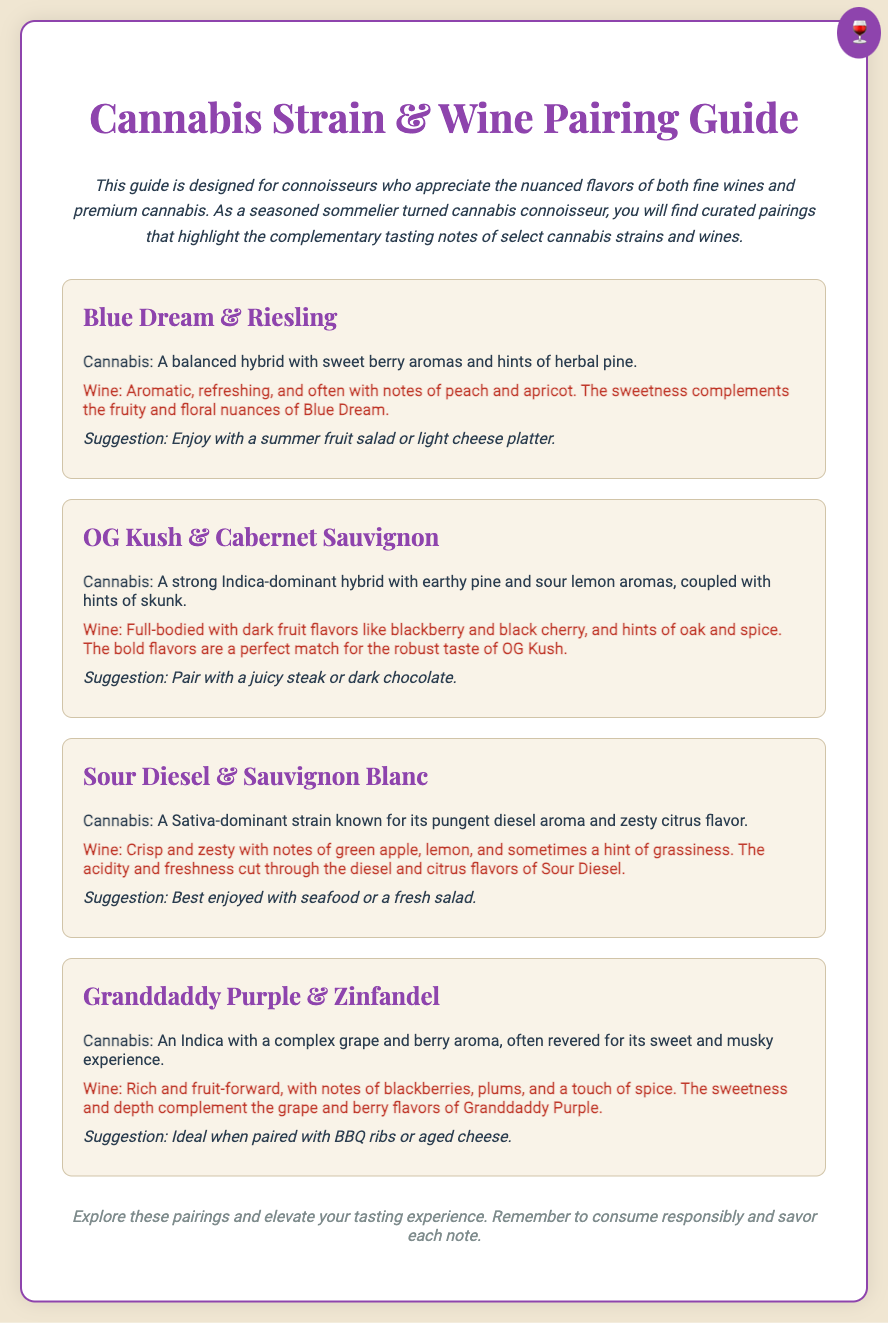What is the title of the guide? The title of the guide is prominently displayed at the top of the document.
Answer: Cannabis Strain & Wine Pairing Guide What strain is paired with Riesling? The document lists various cannabis strains paired with different wines, including the one with Riesling.
Answer: Blue Dream What type of wine is paired with Sour Diesel? Each cannabis strain includes its complementary wine. The one paired with Sour Diesel is identified in the document.
Answer: Sauvignon Blanc What flavor notes are associated with OG Kush? The document describes the flavors for each cannabis strain, including OG Kush.
Answer: Earthy pine and sour lemon What is a suggested food pairing with Granddaddy Purple? The document provides suggestions for food pairings alongside each cannabis strain.
Answer: BBQ ribs Which cannabis strain is described as having a pungent diesel aroma? Each strain is characterized by its unique aroma. This specific strain is mentioned in the document.
Answer: Sour Diesel What is the main aroma note of Blue Dream? The aroma of each strain is detailed, including Blue Dream.
Answer: Sweet berry aromas How does the wine paired with Zinfandel complement Granddaddy Purple? This question requires reasoning regarding the tasting notes of both the wine and cannabis strain, which are compared in the document.
Answer: Sweetness and depth complement the grape and berry flavors What is the color of the envelope's stamp? The stamp in the document's design is described explicitly.
Answer: Purple 